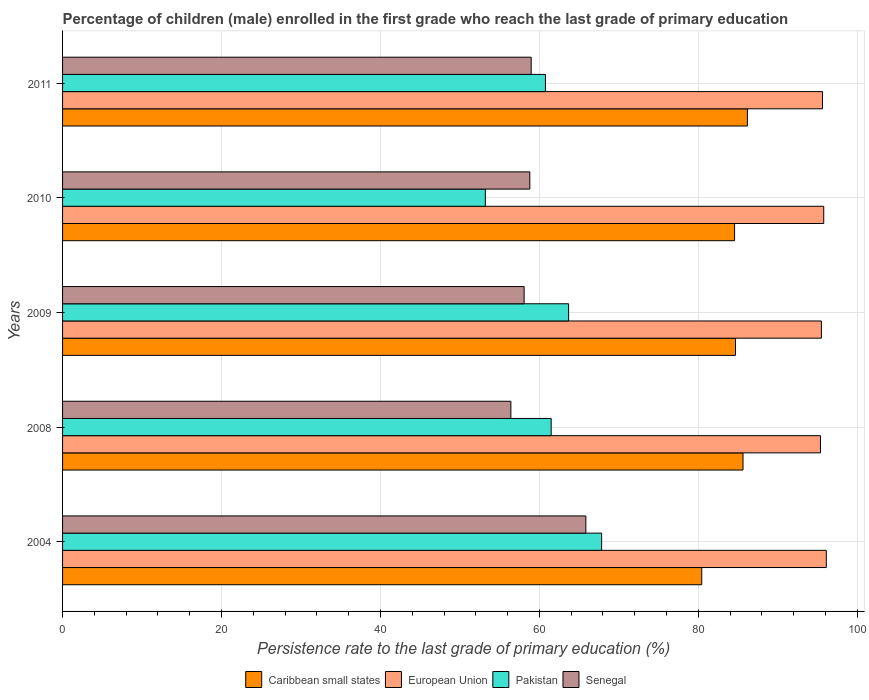How many different coloured bars are there?
Your answer should be compact. 4. How many groups of bars are there?
Your answer should be compact. 5. Are the number of bars per tick equal to the number of legend labels?
Make the answer very short. Yes. How many bars are there on the 5th tick from the bottom?
Offer a very short reply. 4. What is the label of the 2nd group of bars from the top?
Provide a short and direct response. 2010. In how many cases, is the number of bars for a given year not equal to the number of legend labels?
Offer a terse response. 0. What is the persistence rate of children in Senegal in 2008?
Provide a short and direct response. 56.42. Across all years, what is the maximum persistence rate of children in Pakistan?
Provide a short and direct response. 67.84. Across all years, what is the minimum persistence rate of children in European Union?
Keep it short and to the point. 95.38. In which year was the persistence rate of children in Caribbean small states minimum?
Your answer should be compact. 2004. What is the total persistence rate of children in European Union in the graph?
Ensure brevity in your answer.  478.4. What is the difference between the persistence rate of children in European Union in 2004 and that in 2010?
Offer a terse response. 0.32. What is the difference between the persistence rate of children in Senegal in 2010 and the persistence rate of children in European Union in 2008?
Offer a very short reply. -36.58. What is the average persistence rate of children in Senegal per year?
Keep it short and to the point. 59.62. In the year 2004, what is the difference between the persistence rate of children in Pakistan and persistence rate of children in Senegal?
Your response must be concise. 1.99. In how many years, is the persistence rate of children in European Union greater than 56 %?
Your answer should be compact. 5. What is the ratio of the persistence rate of children in Caribbean small states in 2008 to that in 2010?
Offer a very short reply. 1.01. What is the difference between the highest and the second highest persistence rate of children in Pakistan?
Your answer should be compact. 4.16. What is the difference between the highest and the lowest persistence rate of children in Caribbean small states?
Keep it short and to the point. 5.75. In how many years, is the persistence rate of children in Pakistan greater than the average persistence rate of children in Pakistan taken over all years?
Keep it short and to the point. 3. Is it the case that in every year, the sum of the persistence rate of children in Caribbean small states and persistence rate of children in European Union is greater than the sum of persistence rate of children in Pakistan and persistence rate of children in Senegal?
Make the answer very short. Yes. What does the 2nd bar from the top in 2004 represents?
Your answer should be very brief. Pakistan. What does the 1st bar from the bottom in 2011 represents?
Your response must be concise. Caribbean small states. How many bars are there?
Offer a very short reply. 20. What is the difference between two consecutive major ticks on the X-axis?
Give a very brief answer. 20. Are the values on the major ticks of X-axis written in scientific E-notation?
Offer a very short reply. No. Does the graph contain any zero values?
Your answer should be compact. No. Does the graph contain grids?
Provide a short and direct response. Yes. Where does the legend appear in the graph?
Ensure brevity in your answer.  Bottom center. What is the title of the graph?
Make the answer very short. Percentage of children (male) enrolled in the first grade who reach the last grade of primary education. What is the label or title of the X-axis?
Offer a terse response. Persistence rate to the last grade of primary education (%). What is the Persistence rate to the last grade of primary education (%) of Caribbean small states in 2004?
Keep it short and to the point. 80.44. What is the Persistence rate to the last grade of primary education (%) in European Union in 2004?
Your answer should be very brief. 96.11. What is the Persistence rate to the last grade of primary education (%) of Pakistan in 2004?
Make the answer very short. 67.84. What is the Persistence rate to the last grade of primary education (%) in Senegal in 2004?
Your answer should be compact. 65.85. What is the Persistence rate to the last grade of primary education (%) of Caribbean small states in 2008?
Give a very brief answer. 85.63. What is the Persistence rate to the last grade of primary education (%) in European Union in 2008?
Make the answer very short. 95.38. What is the Persistence rate to the last grade of primary education (%) of Pakistan in 2008?
Your response must be concise. 61.49. What is the Persistence rate to the last grade of primary education (%) in Senegal in 2008?
Your response must be concise. 56.42. What is the Persistence rate to the last grade of primary education (%) of Caribbean small states in 2009?
Provide a succinct answer. 84.69. What is the Persistence rate to the last grade of primary education (%) in European Union in 2009?
Your answer should be very brief. 95.49. What is the Persistence rate to the last grade of primary education (%) in Pakistan in 2009?
Make the answer very short. 63.68. What is the Persistence rate to the last grade of primary education (%) in Senegal in 2009?
Provide a succinct answer. 58.08. What is the Persistence rate to the last grade of primary education (%) in Caribbean small states in 2010?
Give a very brief answer. 84.57. What is the Persistence rate to the last grade of primary education (%) in European Union in 2010?
Your response must be concise. 95.79. What is the Persistence rate to the last grade of primary education (%) of Pakistan in 2010?
Your answer should be very brief. 53.2. What is the Persistence rate to the last grade of primary education (%) in Senegal in 2010?
Provide a short and direct response. 58.8. What is the Persistence rate to the last grade of primary education (%) in Caribbean small states in 2011?
Offer a very short reply. 86.18. What is the Persistence rate to the last grade of primary education (%) of European Union in 2011?
Give a very brief answer. 95.63. What is the Persistence rate to the last grade of primary education (%) in Pakistan in 2011?
Your answer should be very brief. 60.77. What is the Persistence rate to the last grade of primary education (%) in Senegal in 2011?
Make the answer very short. 58.97. Across all years, what is the maximum Persistence rate to the last grade of primary education (%) of Caribbean small states?
Offer a very short reply. 86.18. Across all years, what is the maximum Persistence rate to the last grade of primary education (%) of European Union?
Ensure brevity in your answer.  96.11. Across all years, what is the maximum Persistence rate to the last grade of primary education (%) in Pakistan?
Provide a short and direct response. 67.84. Across all years, what is the maximum Persistence rate to the last grade of primary education (%) in Senegal?
Your answer should be very brief. 65.85. Across all years, what is the minimum Persistence rate to the last grade of primary education (%) of Caribbean small states?
Make the answer very short. 80.44. Across all years, what is the minimum Persistence rate to the last grade of primary education (%) in European Union?
Your answer should be compact. 95.38. Across all years, what is the minimum Persistence rate to the last grade of primary education (%) in Pakistan?
Provide a short and direct response. 53.2. Across all years, what is the minimum Persistence rate to the last grade of primary education (%) in Senegal?
Provide a short and direct response. 56.42. What is the total Persistence rate to the last grade of primary education (%) in Caribbean small states in the graph?
Provide a short and direct response. 421.5. What is the total Persistence rate to the last grade of primary education (%) of European Union in the graph?
Your answer should be very brief. 478.4. What is the total Persistence rate to the last grade of primary education (%) of Pakistan in the graph?
Offer a very short reply. 306.98. What is the total Persistence rate to the last grade of primary education (%) of Senegal in the graph?
Your response must be concise. 298.12. What is the difference between the Persistence rate to the last grade of primary education (%) in Caribbean small states in 2004 and that in 2008?
Your answer should be compact. -5.19. What is the difference between the Persistence rate to the last grade of primary education (%) of European Union in 2004 and that in 2008?
Provide a succinct answer. 0.73. What is the difference between the Persistence rate to the last grade of primary education (%) in Pakistan in 2004 and that in 2008?
Keep it short and to the point. 6.35. What is the difference between the Persistence rate to the last grade of primary education (%) of Senegal in 2004 and that in 2008?
Make the answer very short. 9.43. What is the difference between the Persistence rate to the last grade of primary education (%) in Caribbean small states in 2004 and that in 2009?
Give a very brief answer. -4.25. What is the difference between the Persistence rate to the last grade of primary education (%) in European Union in 2004 and that in 2009?
Ensure brevity in your answer.  0.62. What is the difference between the Persistence rate to the last grade of primary education (%) in Pakistan in 2004 and that in 2009?
Provide a succinct answer. 4.16. What is the difference between the Persistence rate to the last grade of primary education (%) of Senegal in 2004 and that in 2009?
Offer a terse response. 7.77. What is the difference between the Persistence rate to the last grade of primary education (%) of Caribbean small states in 2004 and that in 2010?
Your response must be concise. -4.13. What is the difference between the Persistence rate to the last grade of primary education (%) in European Union in 2004 and that in 2010?
Provide a succinct answer. 0.32. What is the difference between the Persistence rate to the last grade of primary education (%) of Pakistan in 2004 and that in 2010?
Provide a short and direct response. 14.64. What is the difference between the Persistence rate to the last grade of primary education (%) in Senegal in 2004 and that in 2010?
Provide a succinct answer. 7.05. What is the difference between the Persistence rate to the last grade of primary education (%) of Caribbean small states in 2004 and that in 2011?
Offer a very short reply. -5.75. What is the difference between the Persistence rate to the last grade of primary education (%) of European Union in 2004 and that in 2011?
Your answer should be compact. 0.48. What is the difference between the Persistence rate to the last grade of primary education (%) in Pakistan in 2004 and that in 2011?
Offer a terse response. 7.07. What is the difference between the Persistence rate to the last grade of primary education (%) in Senegal in 2004 and that in 2011?
Your answer should be very brief. 6.88. What is the difference between the Persistence rate to the last grade of primary education (%) in Caribbean small states in 2008 and that in 2009?
Keep it short and to the point. 0.95. What is the difference between the Persistence rate to the last grade of primary education (%) in European Union in 2008 and that in 2009?
Make the answer very short. -0.12. What is the difference between the Persistence rate to the last grade of primary education (%) in Pakistan in 2008 and that in 2009?
Your response must be concise. -2.19. What is the difference between the Persistence rate to the last grade of primary education (%) of Senegal in 2008 and that in 2009?
Ensure brevity in your answer.  -1.67. What is the difference between the Persistence rate to the last grade of primary education (%) in Caribbean small states in 2008 and that in 2010?
Make the answer very short. 1.06. What is the difference between the Persistence rate to the last grade of primary education (%) in European Union in 2008 and that in 2010?
Your response must be concise. -0.41. What is the difference between the Persistence rate to the last grade of primary education (%) of Pakistan in 2008 and that in 2010?
Your answer should be compact. 8.28. What is the difference between the Persistence rate to the last grade of primary education (%) in Senegal in 2008 and that in 2010?
Your response must be concise. -2.38. What is the difference between the Persistence rate to the last grade of primary education (%) of Caribbean small states in 2008 and that in 2011?
Give a very brief answer. -0.55. What is the difference between the Persistence rate to the last grade of primary education (%) in European Union in 2008 and that in 2011?
Offer a very short reply. -0.25. What is the difference between the Persistence rate to the last grade of primary education (%) of Pakistan in 2008 and that in 2011?
Your answer should be compact. 0.72. What is the difference between the Persistence rate to the last grade of primary education (%) of Senegal in 2008 and that in 2011?
Your answer should be compact. -2.55. What is the difference between the Persistence rate to the last grade of primary education (%) of Caribbean small states in 2009 and that in 2010?
Your response must be concise. 0.12. What is the difference between the Persistence rate to the last grade of primary education (%) of European Union in 2009 and that in 2010?
Your response must be concise. -0.29. What is the difference between the Persistence rate to the last grade of primary education (%) of Pakistan in 2009 and that in 2010?
Offer a terse response. 10.48. What is the difference between the Persistence rate to the last grade of primary education (%) in Senegal in 2009 and that in 2010?
Keep it short and to the point. -0.72. What is the difference between the Persistence rate to the last grade of primary education (%) of Caribbean small states in 2009 and that in 2011?
Provide a succinct answer. -1.5. What is the difference between the Persistence rate to the last grade of primary education (%) in European Union in 2009 and that in 2011?
Ensure brevity in your answer.  -0.14. What is the difference between the Persistence rate to the last grade of primary education (%) of Pakistan in 2009 and that in 2011?
Your answer should be very brief. 2.92. What is the difference between the Persistence rate to the last grade of primary education (%) in Senegal in 2009 and that in 2011?
Your answer should be compact. -0.89. What is the difference between the Persistence rate to the last grade of primary education (%) of Caribbean small states in 2010 and that in 2011?
Keep it short and to the point. -1.61. What is the difference between the Persistence rate to the last grade of primary education (%) in European Union in 2010 and that in 2011?
Keep it short and to the point. 0.16. What is the difference between the Persistence rate to the last grade of primary education (%) of Pakistan in 2010 and that in 2011?
Provide a short and direct response. -7.56. What is the difference between the Persistence rate to the last grade of primary education (%) of Senegal in 2010 and that in 2011?
Offer a very short reply. -0.17. What is the difference between the Persistence rate to the last grade of primary education (%) in Caribbean small states in 2004 and the Persistence rate to the last grade of primary education (%) in European Union in 2008?
Give a very brief answer. -14.94. What is the difference between the Persistence rate to the last grade of primary education (%) of Caribbean small states in 2004 and the Persistence rate to the last grade of primary education (%) of Pakistan in 2008?
Ensure brevity in your answer.  18.95. What is the difference between the Persistence rate to the last grade of primary education (%) in Caribbean small states in 2004 and the Persistence rate to the last grade of primary education (%) in Senegal in 2008?
Provide a short and direct response. 24.02. What is the difference between the Persistence rate to the last grade of primary education (%) of European Union in 2004 and the Persistence rate to the last grade of primary education (%) of Pakistan in 2008?
Provide a succinct answer. 34.62. What is the difference between the Persistence rate to the last grade of primary education (%) in European Union in 2004 and the Persistence rate to the last grade of primary education (%) in Senegal in 2008?
Offer a terse response. 39.69. What is the difference between the Persistence rate to the last grade of primary education (%) of Pakistan in 2004 and the Persistence rate to the last grade of primary education (%) of Senegal in 2008?
Your answer should be very brief. 11.42. What is the difference between the Persistence rate to the last grade of primary education (%) of Caribbean small states in 2004 and the Persistence rate to the last grade of primary education (%) of European Union in 2009?
Give a very brief answer. -15.06. What is the difference between the Persistence rate to the last grade of primary education (%) of Caribbean small states in 2004 and the Persistence rate to the last grade of primary education (%) of Pakistan in 2009?
Ensure brevity in your answer.  16.75. What is the difference between the Persistence rate to the last grade of primary education (%) of Caribbean small states in 2004 and the Persistence rate to the last grade of primary education (%) of Senegal in 2009?
Your answer should be very brief. 22.35. What is the difference between the Persistence rate to the last grade of primary education (%) in European Union in 2004 and the Persistence rate to the last grade of primary education (%) in Pakistan in 2009?
Your answer should be very brief. 32.43. What is the difference between the Persistence rate to the last grade of primary education (%) of European Union in 2004 and the Persistence rate to the last grade of primary education (%) of Senegal in 2009?
Offer a very short reply. 38.03. What is the difference between the Persistence rate to the last grade of primary education (%) of Pakistan in 2004 and the Persistence rate to the last grade of primary education (%) of Senegal in 2009?
Offer a very short reply. 9.75. What is the difference between the Persistence rate to the last grade of primary education (%) of Caribbean small states in 2004 and the Persistence rate to the last grade of primary education (%) of European Union in 2010?
Your answer should be very brief. -15.35. What is the difference between the Persistence rate to the last grade of primary education (%) of Caribbean small states in 2004 and the Persistence rate to the last grade of primary education (%) of Pakistan in 2010?
Provide a short and direct response. 27.23. What is the difference between the Persistence rate to the last grade of primary education (%) of Caribbean small states in 2004 and the Persistence rate to the last grade of primary education (%) of Senegal in 2010?
Ensure brevity in your answer.  21.64. What is the difference between the Persistence rate to the last grade of primary education (%) of European Union in 2004 and the Persistence rate to the last grade of primary education (%) of Pakistan in 2010?
Ensure brevity in your answer.  42.91. What is the difference between the Persistence rate to the last grade of primary education (%) in European Union in 2004 and the Persistence rate to the last grade of primary education (%) in Senegal in 2010?
Your answer should be very brief. 37.31. What is the difference between the Persistence rate to the last grade of primary education (%) in Pakistan in 2004 and the Persistence rate to the last grade of primary education (%) in Senegal in 2010?
Keep it short and to the point. 9.04. What is the difference between the Persistence rate to the last grade of primary education (%) in Caribbean small states in 2004 and the Persistence rate to the last grade of primary education (%) in European Union in 2011?
Keep it short and to the point. -15.19. What is the difference between the Persistence rate to the last grade of primary education (%) of Caribbean small states in 2004 and the Persistence rate to the last grade of primary education (%) of Pakistan in 2011?
Make the answer very short. 19.67. What is the difference between the Persistence rate to the last grade of primary education (%) of Caribbean small states in 2004 and the Persistence rate to the last grade of primary education (%) of Senegal in 2011?
Provide a succinct answer. 21.47. What is the difference between the Persistence rate to the last grade of primary education (%) in European Union in 2004 and the Persistence rate to the last grade of primary education (%) in Pakistan in 2011?
Provide a succinct answer. 35.34. What is the difference between the Persistence rate to the last grade of primary education (%) in European Union in 2004 and the Persistence rate to the last grade of primary education (%) in Senegal in 2011?
Offer a very short reply. 37.14. What is the difference between the Persistence rate to the last grade of primary education (%) in Pakistan in 2004 and the Persistence rate to the last grade of primary education (%) in Senegal in 2011?
Your response must be concise. 8.87. What is the difference between the Persistence rate to the last grade of primary education (%) of Caribbean small states in 2008 and the Persistence rate to the last grade of primary education (%) of European Union in 2009?
Ensure brevity in your answer.  -9.86. What is the difference between the Persistence rate to the last grade of primary education (%) in Caribbean small states in 2008 and the Persistence rate to the last grade of primary education (%) in Pakistan in 2009?
Your response must be concise. 21.95. What is the difference between the Persistence rate to the last grade of primary education (%) in Caribbean small states in 2008 and the Persistence rate to the last grade of primary education (%) in Senegal in 2009?
Ensure brevity in your answer.  27.55. What is the difference between the Persistence rate to the last grade of primary education (%) in European Union in 2008 and the Persistence rate to the last grade of primary education (%) in Pakistan in 2009?
Keep it short and to the point. 31.69. What is the difference between the Persistence rate to the last grade of primary education (%) of European Union in 2008 and the Persistence rate to the last grade of primary education (%) of Senegal in 2009?
Provide a succinct answer. 37.29. What is the difference between the Persistence rate to the last grade of primary education (%) of Pakistan in 2008 and the Persistence rate to the last grade of primary education (%) of Senegal in 2009?
Ensure brevity in your answer.  3.4. What is the difference between the Persistence rate to the last grade of primary education (%) of Caribbean small states in 2008 and the Persistence rate to the last grade of primary education (%) of European Union in 2010?
Give a very brief answer. -10.16. What is the difference between the Persistence rate to the last grade of primary education (%) of Caribbean small states in 2008 and the Persistence rate to the last grade of primary education (%) of Pakistan in 2010?
Your answer should be compact. 32.43. What is the difference between the Persistence rate to the last grade of primary education (%) of Caribbean small states in 2008 and the Persistence rate to the last grade of primary education (%) of Senegal in 2010?
Provide a succinct answer. 26.83. What is the difference between the Persistence rate to the last grade of primary education (%) of European Union in 2008 and the Persistence rate to the last grade of primary education (%) of Pakistan in 2010?
Give a very brief answer. 42.17. What is the difference between the Persistence rate to the last grade of primary education (%) of European Union in 2008 and the Persistence rate to the last grade of primary education (%) of Senegal in 2010?
Provide a short and direct response. 36.58. What is the difference between the Persistence rate to the last grade of primary education (%) in Pakistan in 2008 and the Persistence rate to the last grade of primary education (%) in Senegal in 2010?
Make the answer very short. 2.69. What is the difference between the Persistence rate to the last grade of primary education (%) in Caribbean small states in 2008 and the Persistence rate to the last grade of primary education (%) in European Union in 2011?
Make the answer very short. -10. What is the difference between the Persistence rate to the last grade of primary education (%) in Caribbean small states in 2008 and the Persistence rate to the last grade of primary education (%) in Pakistan in 2011?
Keep it short and to the point. 24.86. What is the difference between the Persistence rate to the last grade of primary education (%) of Caribbean small states in 2008 and the Persistence rate to the last grade of primary education (%) of Senegal in 2011?
Your answer should be very brief. 26.66. What is the difference between the Persistence rate to the last grade of primary education (%) in European Union in 2008 and the Persistence rate to the last grade of primary education (%) in Pakistan in 2011?
Provide a succinct answer. 34.61. What is the difference between the Persistence rate to the last grade of primary education (%) of European Union in 2008 and the Persistence rate to the last grade of primary education (%) of Senegal in 2011?
Keep it short and to the point. 36.41. What is the difference between the Persistence rate to the last grade of primary education (%) of Pakistan in 2008 and the Persistence rate to the last grade of primary education (%) of Senegal in 2011?
Your response must be concise. 2.52. What is the difference between the Persistence rate to the last grade of primary education (%) of Caribbean small states in 2009 and the Persistence rate to the last grade of primary education (%) of European Union in 2010?
Offer a very short reply. -11.1. What is the difference between the Persistence rate to the last grade of primary education (%) in Caribbean small states in 2009 and the Persistence rate to the last grade of primary education (%) in Pakistan in 2010?
Provide a succinct answer. 31.48. What is the difference between the Persistence rate to the last grade of primary education (%) of Caribbean small states in 2009 and the Persistence rate to the last grade of primary education (%) of Senegal in 2010?
Your answer should be compact. 25.89. What is the difference between the Persistence rate to the last grade of primary education (%) of European Union in 2009 and the Persistence rate to the last grade of primary education (%) of Pakistan in 2010?
Provide a succinct answer. 42.29. What is the difference between the Persistence rate to the last grade of primary education (%) in European Union in 2009 and the Persistence rate to the last grade of primary education (%) in Senegal in 2010?
Your response must be concise. 36.69. What is the difference between the Persistence rate to the last grade of primary education (%) of Pakistan in 2009 and the Persistence rate to the last grade of primary education (%) of Senegal in 2010?
Give a very brief answer. 4.88. What is the difference between the Persistence rate to the last grade of primary education (%) in Caribbean small states in 2009 and the Persistence rate to the last grade of primary education (%) in European Union in 2011?
Provide a short and direct response. -10.95. What is the difference between the Persistence rate to the last grade of primary education (%) in Caribbean small states in 2009 and the Persistence rate to the last grade of primary education (%) in Pakistan in 2011?
Keep it short and to the point. 23.92. What is the difference between the Persistence rate to the last grade of primary education (%) in Caribbean small states in 2009 and the Persistence rate to the last grade of primary education (%) in Senegal in 2011?
Your answer should be compact. 25.71. What is the difference between the Persistence rate to the last grade of primary education (%) in European Union in 2009 and the Persistence rate to the last grade of primary education (%) in Pakistan in 2011?
Give a very brief answer. 34.73. What is the difference between the Persistence rate to the last grade of primary education (%) in European Union in 2009 and the Persistence rate to the last grade of primary education (%) in Senegal in 2011?
Your answer should be compact. 36.52. What is the difference between the Persistence rate to the last grade of primary education (%) in Pakistan in 2009 and the Persistence rate to the last grade of primary education (%) in Senegal in 2011?
Keep it short and to the point. 4.71. What is the difference between the Persistence rate to the last grade of primary education (%) of Caribbean small states in 2010 and the Persistence rate to the last grade of primary education (%) of European Union in 2011?
Make the answer very short. -11.06. What is the difference between the Persistence rate to the last grade of primary education (%) of Caribbean small states in 2010 and the Persistence rate to the last grade of primary education (%) of Pakistan in 2011?
Make the answer very short. 23.8. What is the difference between the Persistence rate to the last grade of primary education (%) in Caribbean small states in 2010 and the Persistence rate to the last grade of primary education (%) in Senegal in 2011?
Ensure brevity in your answer.  25.6. What is the difference between the Persistence rate to the last grade of primary education (%) of European Union in 2010 and the Persistence rate to the last grade of primary education (%) of Pakistan in 2011?
Offer a terse response. 35.02. What is the difference between the Persistence rate to the last grade of primary education (%) in European Union in 2010 and the Persistence rate to the last grade of primary education (%) in Senegal in 2011?
Your answer should be very brief. 36.82. What is the difference between the Persistence rate to the last grade of primary education (%) of Pakistan in 2010 and the Persistence rate to the last grade of primary education (%) of Senegal in 2011?
Provide a succinct answer. -5.77. What is the average Persistence rate to the last grade of primary education (%) in Caribbean small states per year?
Ensure brevity in your answer.  84.3. What is the average Persistence rate to the last grade of primary education (%) of European Union per year?
Offer a very short reply. 95.68. What is the average Persistence rate to the last grade of primary education (%) in Pakistan per year?
Provide a succinct answer. 61.4. What is the average Persistence rate to the last grade of primary education (%) in Senegal per year?
Your answer should be very brief. 59.62. In the year 2004, what is the difference between the Persistence rate to the last grade of primary education (%) of Caribbean small states and Persistence rate to the last grade of primary education (%) of European Union?
Offer a very short reply. -15.67. In the year 2004, what is the difference between the Persistence rate to the last grade of primary education (%) in Caribbean small states and Persistence rate to the last grade of primary education (%) in Pakistan?
Offer a terse response. 12.6. In the year 2004, what is the difference between the Persistence rate to the last grade of primary education (%) in Caribbean small states and Persistence rate to the last grade of primary education (%) in Senegal?
Your answer should be very brief. 14.59. In the year 2004, what is the difference between the Persistence rate to the last grade of primary education (%) in European Union and Persistence rate to the last grade of primary education (%) in Pakistan?
Give a very brief answer. 28.27. In the year 2004, what is the difference between the Persistence rate to the last grade of primary education (%) of European Union and Persistence rate to the last grade of primary education (%) of Senegal?
Your response must be concise. 30.26. In the year 2004, what is the difference between the Persistence rate to the last grade of primary education (%) of Pakistan and Persistence rate to the last grade of primary education (%) of Senegal?
Give a very brief answer. 1.99. In the year 2008, what is the difference between the Persistence rate to the last grade of primary education (%) of Caribbean small states and Persistence rate to the last grade of primary education (%) of European Union?
Your answer should be compact. -9.75. In the year 2008, what is the difference between the Persistence rate to the last grade of primary education (%) in Caribbean small states and Persistence rate to the last grade of primary education (%) in Pakistan?
Give a very brief answer. 24.14. In the year 2008, what is the difference between the Persistence rate to the last grade of primary education (%) of Caribbean small states and Persistence rate to the last grade of primary education (%) of Senegal?
Your response must be concise. 29.21. In the year 2008, what is the difference between the Persistence rate to the last grade of primary education (%) of European Union and Persistence rate to the last grade of primary education (%) of Pakistan?
Give a very brief answer. 33.89. In the year 2008, what is the difference between the Persistence rate to the last grade of primary education (%) in European Union and Persistence rate to the last grade of primary education (%) in Senegal?
Ensure brevity in your answer.  38.96. In the year 2008, what is the difference between the Persistence rate to the last grade of primary education (%) of Pakistan and Persistence rate to the last grade of primary education (%) of Senegal?
Offer a very short reply. 5.07. In the year 2009, what is the difference between the Persistence rate to the last grade of primary education (%) of Caribbean small states and Persistence rate to the last grade of primary education (%) of European Union?
Provide a short and direct response. -10.81. In the year 2009, what is the difference between the Persistence rate to the last grade of primary education (%) of Caribbean small states and Persistence rate to the last grade of primary education (%) of Pakistan?
Offer a very short reply. 21. In the year 2009, what is the difference between the Persistence rate to the last grade of primary education (%) of Caribbean small states and Persistence rate to the last grade of primary education (%) of Senegal?
Your response must be concise. 26.6. In the year 2009, what is the difference between the Persistence rate to the last grade of primary education (%) in European Union and Persistence rate to the last grade of primary education (%) in Pakistan?
Ensure brevity in your answer.  31.81. In the year 2009, what is the difference between the Persistence rate to the last grade of primary education (%) in European Union and Persistence rate to the last grade of primary education (%) in Senegal?
Your answer should be very brief. 37.41. In the year 2009, what is the difference between the Persistence rate to the last grade of primary education (%) in Pakistan and Persistence rate to the last grade of primary education (%) in Senegal?
Offer a very short reply. 5.6. In the year 2010, what is the difference between the Persistence rate to the last grade of primary education (%) in Caribbean small states and Persistence rate to the last grade of primary education (%) in European Union?
Provide a succinct answer. -11.22. In the year 2010, what is the difference between the Persistence rate to the last grade of primary education (%) of Caribbean small states and Persistence rate to the last grade of primary education (%) of Pakistan?
Ensure brevity in your answer.  31.36. In the year 2010, what is the difference between the Persistence rate to the last grade of primary education (%) in Caribbean small states and Persistence rate to the last grade of primary education (%) in Senegal?
Make the answer very short. 25.77. In the year 2010, what is the difference between the Persistence rate to the last grade of primary education (%) in European Union and Persistence rate to the last grade of primary education (%) in Pakistan?
Offer a terse response. 42.58. In the year 2010, what is the difference between the Persistence rate to the last grade of primary education (%) in European Union and Persistence rate to the last grade of primary education (%) in Senegal?
Your response must be concise. 36.99. In the year 2010, what is the difference between the Persistence rate to the last grade of primary education (%) in Pakistan and Persistence rate to the last grade of primary education (%) in Senegal?
Give a very brief answer. -5.6. In the year 2011, what is the difference between the Persistence rate to the last grade of primary education (%) of Caribbean small states and Persistence rate to the last grade of primary education (%) of European Union?
Ensure brevity in your answer.  -9.45. In the year 2011, what is the difference between the Persistence rate to the last grade of primary education (%) in Caribbean small states and Persistence rate to the last grade of primary education (%) in Pakistan?
Provide a succinct answer. 25.42. In the year 2011, what is the difference between the Persistence rate to the last grade of primary education (%) of Caribbean small states and Persistence rate to the last grade of primary education (%) of Senegal?
Provide a short and direct response. 27.21. In the year 2011, what is the difference between the Persistence rate to the last grade of primary education (%) in European Union and Persistence rate to the last grade of primary education (%) in Pakistan?
Your response must be concise. 34.86. In the year 2011, what is the difference between the Persistence rate to the last grade of primary education (%) of European Union and Persistence rate to the last grade of primary education (%) of Senegal?
Your response must be concise. 36.66. In the year 2011, what is the difference between the Persistence rate to the last grade of primary education (%) in Pakistan and Persistence rate to the last grade of primary education (%) in Senegal?
Keep it short and to the point. 1.8. What is the ratio of the Persistence rate to the last grade of primary education (%) of Caribbean small states in 2004 to that in 2008?
Provide a succinct answer. 0.94. What is the ratio of the Persistence rate to the last grade of primary education (%) in European Union in 2004 to that in 2008?
Provide a short and direct response. 1.01. What is the ratio of the Persistence rate to the last grade of primary education (%) of Pakistan in 2004 to that in 2008?
Offer a very short reply. 1.1. What is the ratio of the Persistence rate to the last grade of primary education (%) in Senegal in 2004 to that in 2008?
Your answer should be compact. 1.17. What is the ratio of the Persistence rate to the last grade of primary education (%) of Caribbean small states in 2004 to that in 2009?
Your response must be concise. 0.95. What is the ratio of the Persistence rate to the last grade of primary education (%) of Pakistan in 2004 to that in 2009?
Give a very brief answer. 1.07. What is the ratio of the Persistence rate to the last grade of primary education (%) in Senegal in 2004 to that in 2009?
Provide a succinct answer. 1.13. What is the ratio of the Persistence rate to the last grade of primary education (%) in Caribbean small states in 2004 to that in 2010?
Your answer should be compact. 0.95. What is the ratio of the Persistence rate to the last grade of primary education (%) of European Union in 2004 to that in 2010?
Offer a terse response. 1. What is the ratio of the Persistence rate to the last grade of primary education (%) of Pakistan in 2004 to that in 2010?
Make the answer very short. 1.28. What is the ratio of the Persistence rate to the last grade of primary education (%) in Senegal in 2004 to that in 2010?
Provide a short and direct response. 1.12. What is the ratio of the Persistence rate to the last grade of primary education (%) of Pakistan in 2004 to that in 2011?
Offer a terse response. 1.12. What is the ratio of the Persistence rate to the last grade of primary education (%) of Senegal in 2004 to that in 2011?
Provide a succinct answer. 1.12. What is the ratio of the Persistence rate to the last grade of primary education (%) in Caribbean small states in 2008 to that in 2009?
Your answer should be compact. 1.01. What is the ratio of the Persistence rate to the last grade of primary education (%) of European Union in 2008 to that in 2009?
Your response must be concise. 1. What is the ratio of the Persistence rate to the last grade of primary education (%) in Pakistan in 2008 to that in 2009?
Make the answer very short. 0.97. What is the ratio of the Persistence rate to the last grade of primary education (%) of Senegal in 2008 to that in 2009?
Offer a terse response. 0.97. What is the ratio of the Persistence rate to the last grade of primary education (%) in Caribbean small states in 2008 to that in 2010?
Make the answer very short. 1.01. What is the ratio of the Persistence rate to the last grade of primary education (%) in European Union in 2008 to that in 2010?
Provide a succinct answer. 1. What is the ratio of the Persistence rate to the last grade of primary education (%) in Pakistan in 2008 to that in 2010?
Make the answer very short. 1.16. What is the ratio of the Persistence rate to the last grade of primary education (%) in Senegal in 2008 to that in 2010?
Offer a very short reply. 0.96. What is the ratio of the Persistence rate to the last grade of primary education (%) of Caribbean small states in 2008 to that in 2011?
Your answer should be very brief. 0.99. What is the ratio of the Persistence rate to the last grade of primary education (%) in European Union in 2008 to that in 2011?
Keep it short and to the point. 1. What is the ratio of the Persistence rate to the last grade of primary education (%) of Pakistan in 2008 to that in 2011?
Your response must be concise. 1.01. What is the ratio of the Persistence rate to the last grade of primary education (%) in Senegal in 2008 to that in 2011?
Ensure brevity in your answer.  0.96. What is the ratio of the Persistence rate to the last grade of primary education (%) of Pakistan in 2009 to that in 2010?
Make the answer very short. 1.2. What is the ratio of the Persistence rate to the last grade of primary education (%) in Senegal in 2009 to that in 2010?
Your answer should be compact. 0.99. What is the ratio of the Persistence rate to the last grade of primary education (%) of Caribbean small states in 2009 to that in 2011?
Provide a short and direct response. 0.98. What is the ratio of the Persistence rate to the last grade of primary education (%) in Pakistan in 2009 to that in 2011?
Offer a very short reply. 1.05. What is the ratio of the Persistence rate to the last grade of primary education (%) of Senegal in 2009 to that in 2011?
Your answer should be very brief. 0.98. What is the ratio of the Persistence rate to the last grade of primary education (%) of Caribbean small states in 2010 to that in 2011?
Make the answer very short. 0.98. What is the ratio of the Persistence rate to the last grade of primary education (%) of European Union in 2010 to that in 2011?
Your response must be concise. 1. What is the ratio of the Persistence rate to the last grade of primary education (%) in Pakistan in 2010 to that in 2011?
Your answer should be compact. 0.88. What is the difference between the highest and the second highest Persistence rate to the last grade of primary education (%) in Caribbean small states?
Provide a short and direct response. 0.55. What is the difference between the highest and the second highest Persistence rate to the last grade of primary education (%) of European Union?
Give a very brief answer. 0.32. What is the difference between the highest and the second highest Persistence rate to the last grade of primary education (%) in Pakistan?
Provide a succinct answer. 4.16. What is the difference between the highest and the second highest Persistence rate to the last grade of primary education (%) in Senegal?
Keep it short and to the point. 6.88. What is the difference between the highest and the lowest Persistence rate to the last grade of primary education (%) of Caribbean small states?
Offer a terse response. 5.75. What is the difference between the highest and the lowest Persistence rate to the last grade of primary education (%) of European Union?
Your answer should be very brief. 0.73. What is the difference between the highest and the lowest Persistence rate to the last grade of primary education (%) of Pakistan?
Provide a succinct answer. 14.64. What is the difference between the highest and the lowest Persistence rate to the last grade of primary education (%) in Senegal?
Your answer should be very brief. 9.43. 